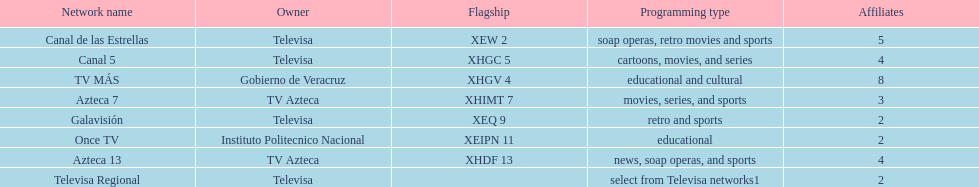How many networks have more affiliates than canal de las estrellas? 1. 